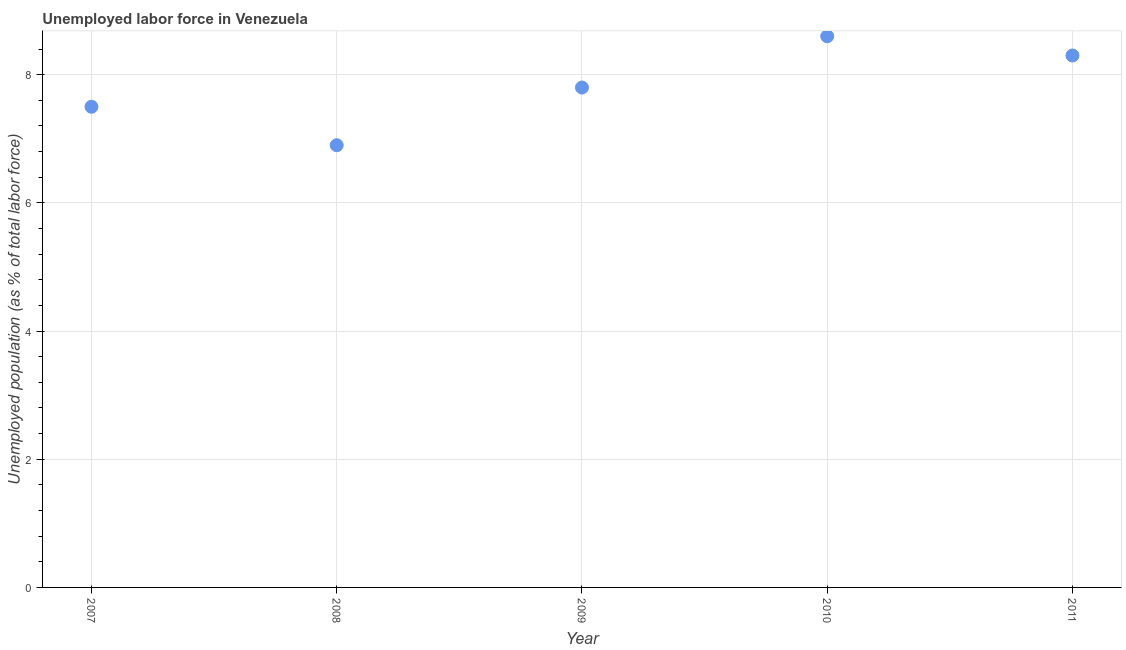What is the total unemployed population in 2009?
Provide a short and direct response. 7.8. Across all years, what is the maximum total unemployed population?
Ensure brevity in your answer.  8.6. Across all years, what is the minimum total unemployed population?
Provide a short and direct response. 6.9. In which year was the total unemployed population maximum?
Offer a terse response. 2010. In which year was the total unemployed population minimum?
Ensure brevity in your answer.  2008. What is the sum of the total unemployed population?
Keep it short and to the point. 39.1. What is the difference between the total unemployed population in 2009 and 2011?
Provide a short and direct response. -0.5. What is the average total unemployed population per year?
Offer a terse response. 7.82. What is the median total unemployed population?
Give a very brief answer. 7.8. What is the ratio of the total unemployed population in 2008 to that in 2009?
Ensure brevity in your answer.  0.88. Is the total unemployed population in 2007 less than that in 2008?
Give a very brief answer. No. What is the difference between the highest and the second highest total unemployed population?
Make the answer very short. 0.3. What is the difference between the highest and the lowest total unemployed population?
Provide a succinct answer. 1.7. Does the total unemployed population monotonically increase over the years?
Ensure brevity in your answer.  No. How many dotlines are there?
Keep it short and to the point. 1. Does the graph contain any zero values?
Provide a succinct answer. No. Does the graph contain grids?
Make the answer very short. Yes. What is the title of the graph?
Your answer should be compact. Unemployed labor force in Venezuela. What is the label or title of the X-axis?
Make the answer very short. Year. What is the label or title of the Y-axis?
Keep it short and to the point. Unemployed population (as % of total labor force). What is the Unemployed population (as % of total labor force) in 2008?
Make the answer very short. 6.9. What is the Unemployed population (as % of total labor force) in 2009?
Keep it short and to the point. 7.8. What is the Unemployed population (as % of total labor force) in 2010?
Provide a succinct answer. 8.6. What is the Unemployed population (as % of total labor force) in 2011?
Provide a succinct answer. 8.3. What is the difference between the Unemployed population (as % of total labor force) in 2007 and 2010?
Your answer should be compact. -1.1. What is the difference between the Unemployed population (as % of total labor force) in 2007 and 2011?
Offer a very short reply. -0.8. What is the difference between the Unemployed population (as % of total labor force) in 2008 and 2010?
Offer a very short reply. -1.7. What is the difference between the Unemployed population (as % of total labor force) in 2008 and 2011?
Make the answer very short. -1.4. What is the difference between the Unemployed population (as % of total labor force) in 2010 and 2011?
Your answer should be compact. 0.3. What is the ratio of the Unemployed population (as % of total labor force) in 2007 to that in 2008?
Your answer should be very brief. 1.09. What is the ratio of the Unemployed population (as % of total labor force) in 2007 to that in 2009?
Offer a terse response. 0.96. What is the ratio of the Unemployed population (as % of total labor force) in 2007 to that in 2010?
Make the answer very short. 0.87. What is the ratio of the Unemployed population (as % of total labor force) in 2007 to that in 2011?
Your answer should be compact. 0.9. What is the ratio of the Unemployed population (as % of total labor force) in 2008 to that in 2009?
Make the answer very short. 0.89. What is the ratio of the Unemployed population (as % of total labor force) in 2008 to that in 2010?
Give a very brief answer. 0.8. What is the ratio of the Unemployed population (as % of total labor force) in 2008 to that in 2011?
Your answer should be very brief. 0.83. What is the ratio of the Unemployed population (as % of total labor force) in 2009 to that in 2010?
Provide a short and direct response. 0.91. What is the ratio of the Unemployed population (as % of total labor force) in 2009 to that in 2011?
Your answer should be compact. 0.94. What is the ratio of the Unemployed population (as % of total labor force) in 2010 to that in 2011?
Keep it short and to the point. 1.04. 